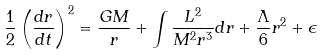Convert formula to latex. <formula><loc_0><loc_0><loc_500><loc_500>\frac { 1 } { 2 } \left ( \frac { d r } { d t } \right ) ^ { 2 } = \frac { G M } { r } + \int \frac { L ^ { 2 } } { M ^ { 2 } r ^ { 3 } } d r + \frac { \Lambda } { 6 } r ^ { 2 } + \epsilon</formula> 